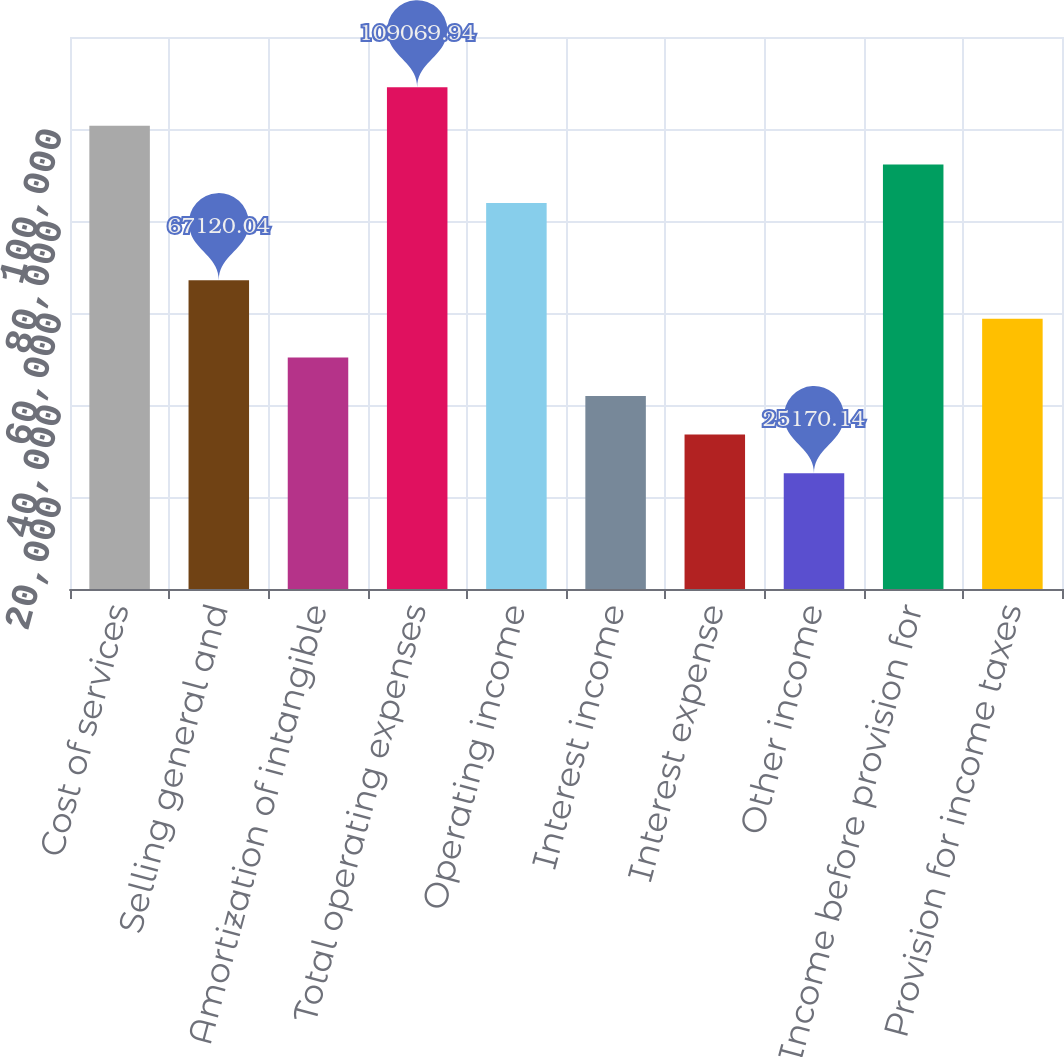Convert chart. <chart><loc_0><loc_0><loc_500><loc_500><bar_chart><fcel>Cost of services<fcel>Selling general and<fcel>Amortization of intangible<fcel>Total operating expenses<fcel>Operating income<fcel>Interest income<fcel>Interest expense<fcel>Other income<fcel>Income before provision for<fcel>Provision for income taxes<nl><fcel>100680<fcel>67120<fcel>50340.1<fcel>109070<fcel>83900<fcel>41950.1<fcel>33560.1<fcel>25170.1<fcel>92290<fcel>58730.1<nl></chart> 